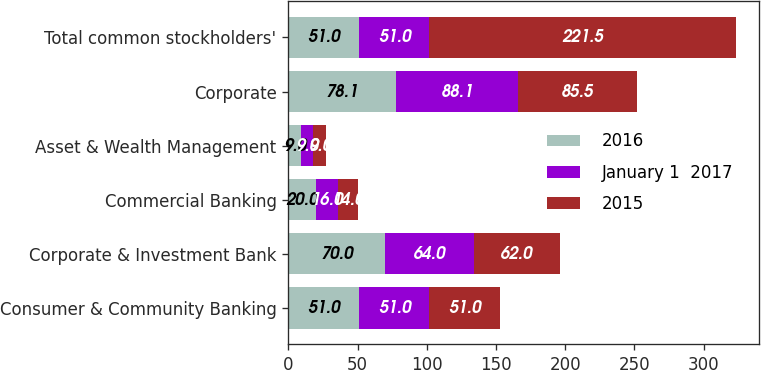Convert chart to OTSL. <chart><loc_0><loc_0><loc_500><loc_500><stacked_bar_chart><ecel><fcel>Consumer & Community Banking<fcel>Corporate & Investment Bank<fcel>Commercial Banking<fcel>Asset & Wealth Management<fcel>Corporate<fcel>Total common stockholders'<nl><fcel>2016<fcel>51<fcel>70<fcel>20<fcel>9<fcel>78.1<fcel>51<nl><fcel>January 1  2017<fcel>51<fcel>64<fcel>16<fcel>9<fcel>88.1<fcel>51<nl><fcel>2015<fcel>51<fcel>62<fcel>14<fcel>9<fcel>85.5<fcel>221.5<nl></chart> 